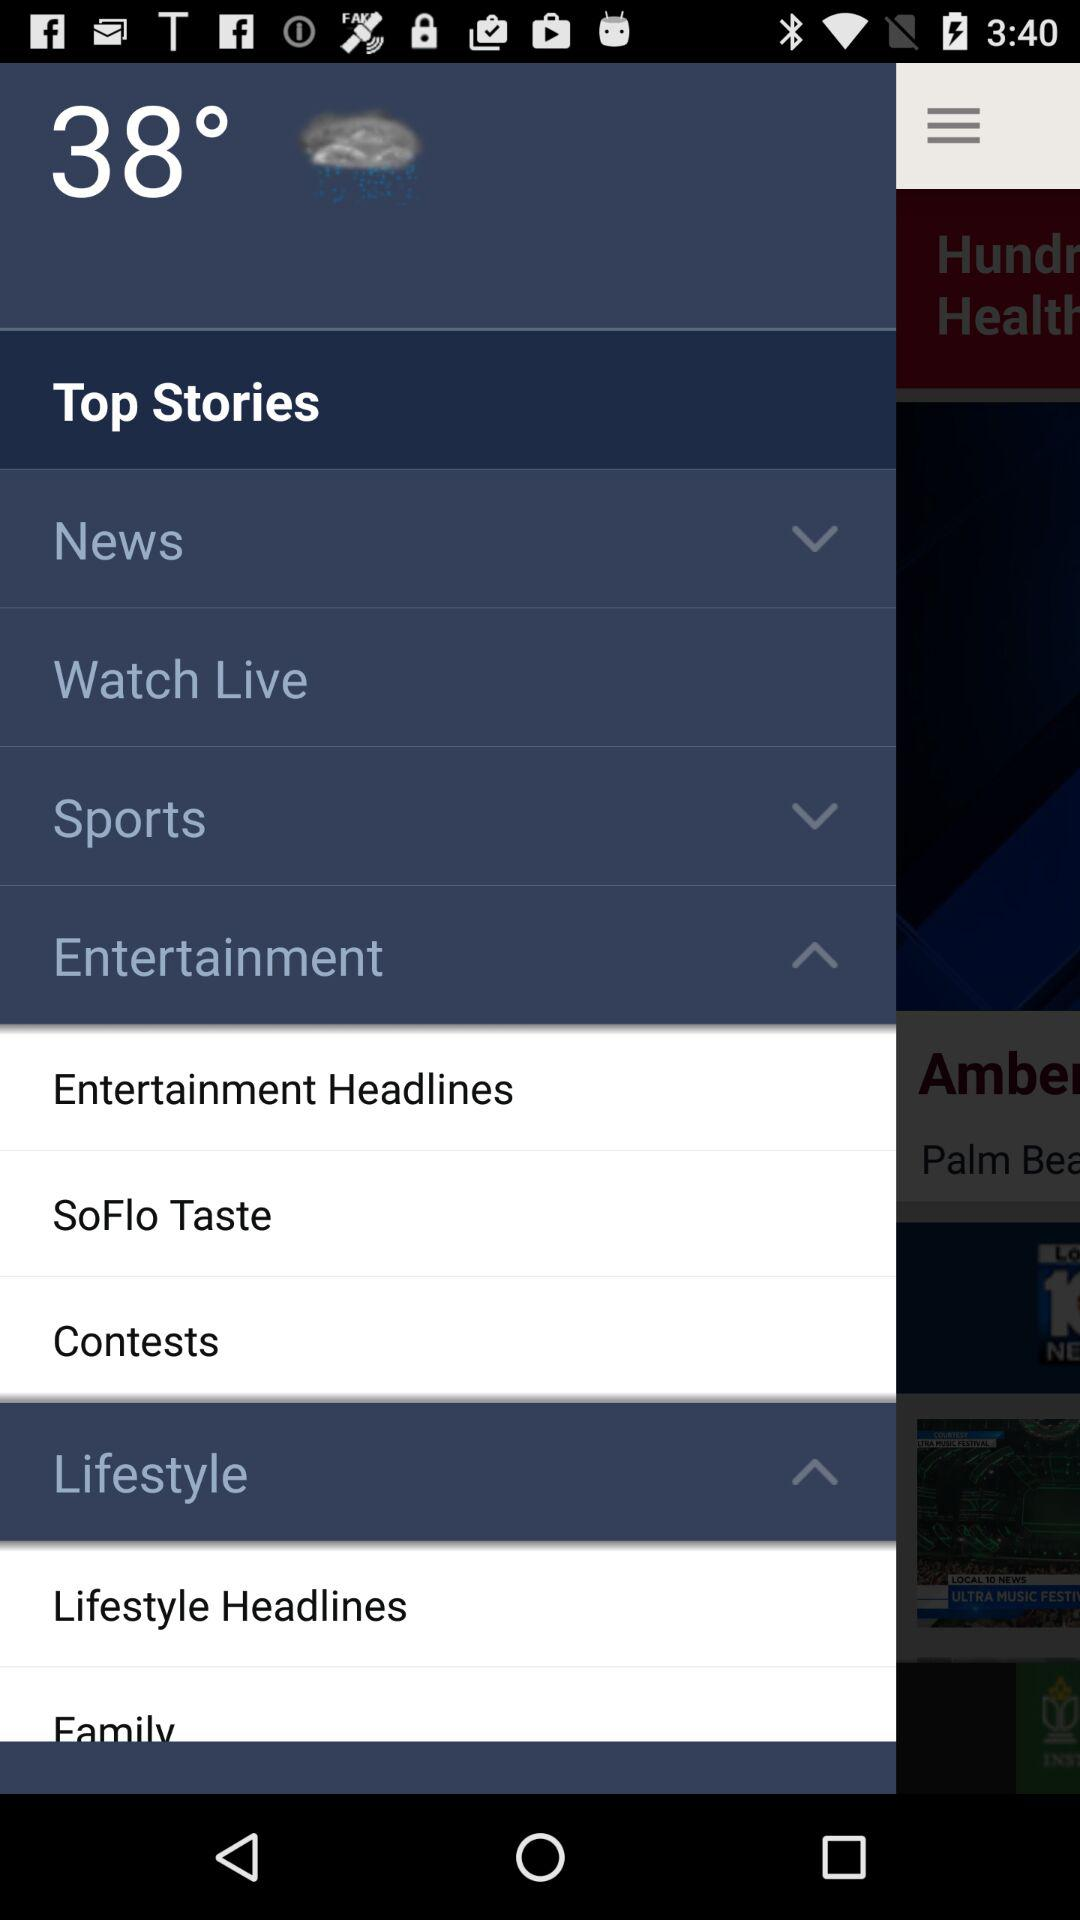What is the temperature? The temperature is 38°. 